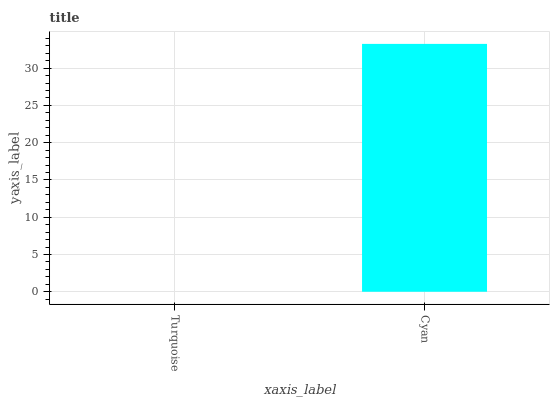Is Turquoise the minimum?
Answer yes or no. Yes. Is Cyan the maximum?
Answer yes or no. Yes. Is Cyan the minimum?
Answer yes or no. No. Is Cyan greater than Turquoise?
Answer yes or no. Yes. Is Turquoise less than Cyan?
Answer yes or no. Yes. Is Turquoise greater than Cyan?
Answer yes or no. No. Is Cyan less than Turquoise?
Answer yes or no. No. Is Cyan the high median?
Answer yes or no. Yes. Is Turquoise the low median?
Answer yes or no. Yes. Is Turquoise the high median?
Answer yes or no. No. Is Cyan the low median?
Answer yes or no. No. 